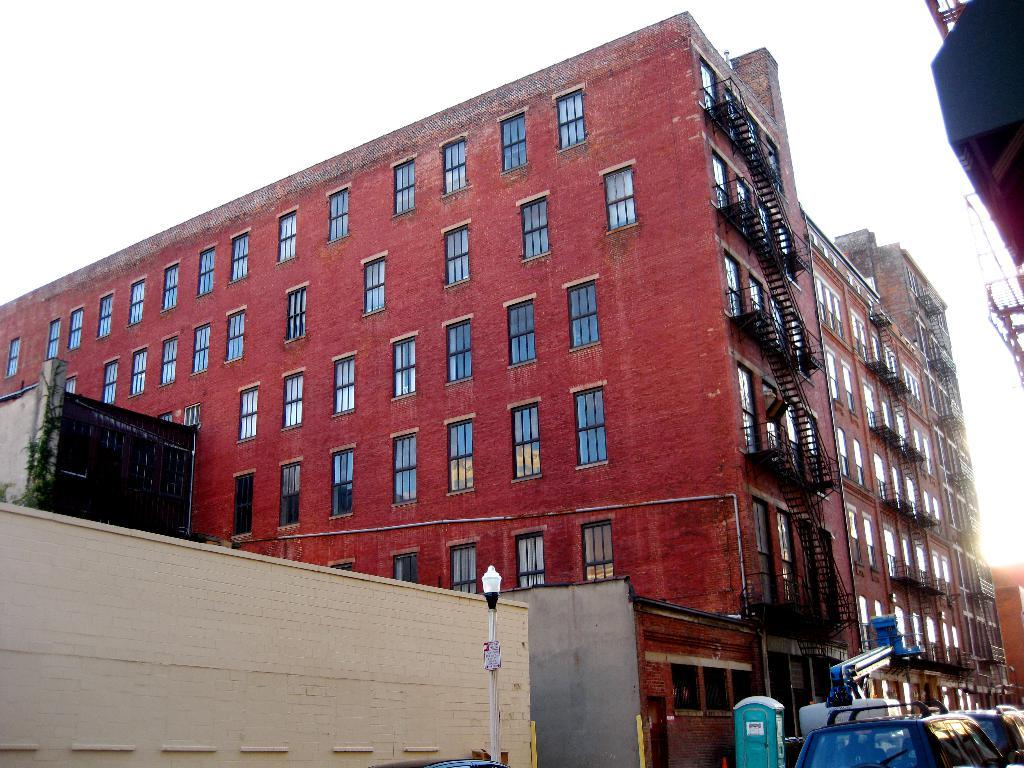What type of view is shown in the image? The image is an outside view. What structures can be seen in the image? There are buildings visible in the image. Where are the cars located in the image? The cars are in the bottom right corner of the image. What is visible at the top of the image? The sky is visible at the top of the image. How many babies are crawling on the roof of the building in the image? There are no babies visible in the image, and no one is crawling on the roof of the building. 